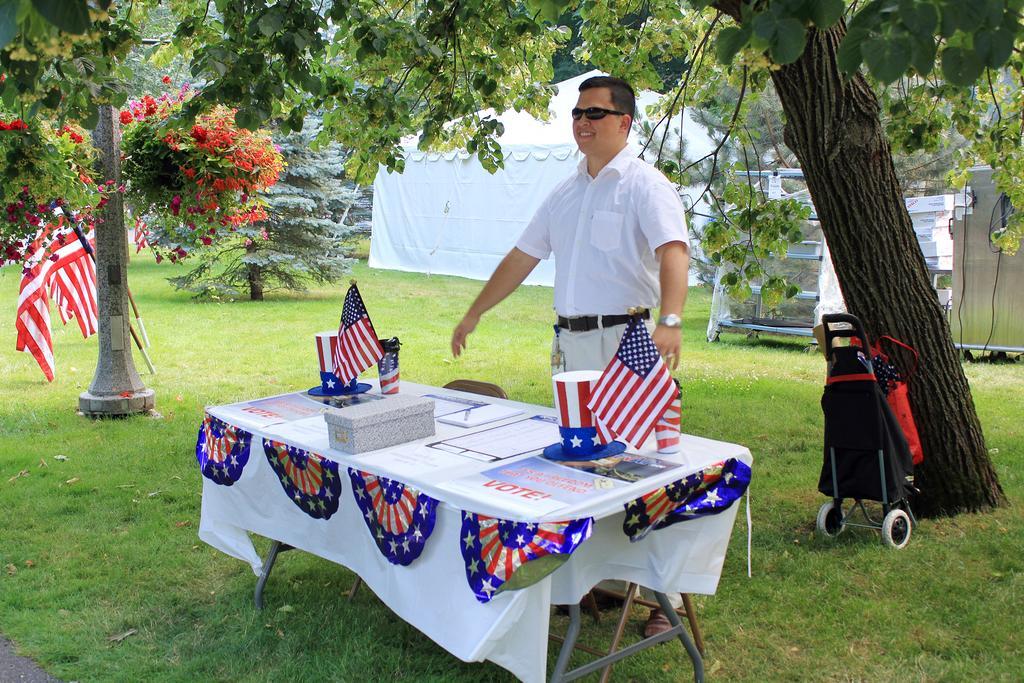How would you summarize this image in a sentence or two? Here is the man standing and smiling. This is the table covered with white cloth. I can see two flags,paper cup and posters on the table. this looks like a small box.. I think this is a stroller. These are the trees. I can find flowers to the trees. This looks like a pillar. This is the tent which is white in color,and here I find flags attached to the sticks. 